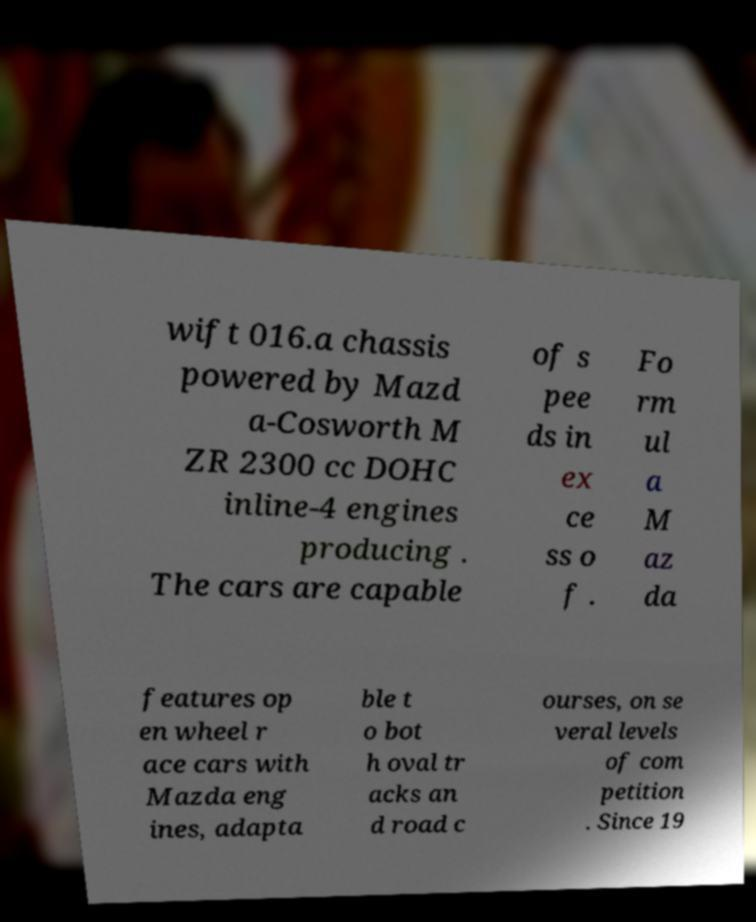Can you read and provide the text displayed in the image?This photo seems to have some interesting text. Can you extract and type it out for me? wift 016.a chassis powered by Mazd a-Cosworth M ZR 2300 cc DOHC inline-4 engines producing . The cars are capable of s pee ds in ex ce ss o f . Fo rm ul a M az da features op en wheel r ace cars with Mazda eng ines, adapta ble t o bot h oval tr acks an d road c ourses, on se veral levels of com petition . Since 19 